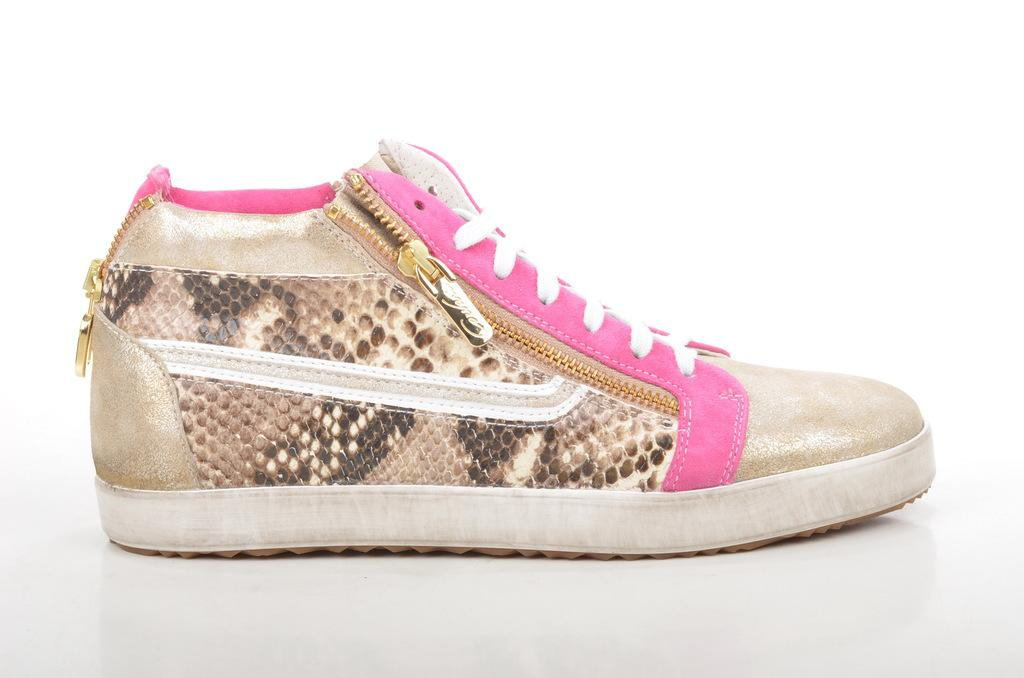What object is the main focus of the image? There is a shoe in the image. What color is the background of the image? The background of the image is white. Can you see a mountain in the background of the image? There is no mountain visible in the image; the background is white. Is there a guide leading a group on a trail in the image? There is no guide or trail present in the image; it only features a shoe and a white background. 